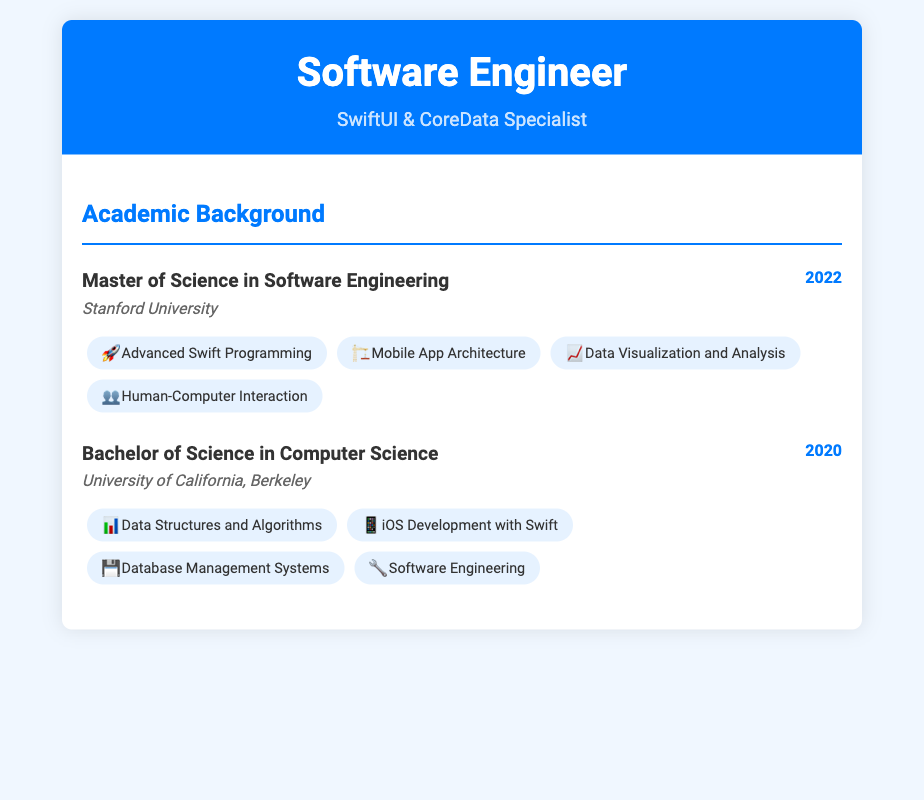What degree was obtained in 2022? The document states the degree obtained in 2022 is a Master of Science in Software Engineering.
Answer: Master of Science in Software Engineering Which university awarded the Bachelor of Science degree? The document lists the University of California, Berkeley as the institution for the Bachelor's degree.
Answer: University of California, Berkeley How many courses are listed under the Master of Science degree? The document specifies four courses listed under the Master of Science degree.
Answer: 4 What year did the individual complete their Bachelor of Science degree? According to the document, the Bachelor of Science degree was completed in 2020.
Answer: 2020 Which course focuses on mobile development? The document mentions the course titled "iOS Development with Swift" as the mobile development course.
Answer: iOS Development with Swift What type of degree is mentioned as being achieved in 2022? The document indicates that a Master of Science degree was achieved in 2022.
Answer: Master of Science Which course addresses data visualization? The course related to data visualization is "Data Visualization and Analysis" as per the document.
Answer: Data Visualization and Analysis What is the primary focus of the coursework in the Bachelor of Science degree? The coursework for the Bachelor's degree primarily focuses on computer science-related subjects.
Answer: Computer Science What is the name of the course that explores Human-Computer Interaction? The document lists "Human-Computer Interaction" as the course exploring this field.
Answer: Human-Computer Interaction 